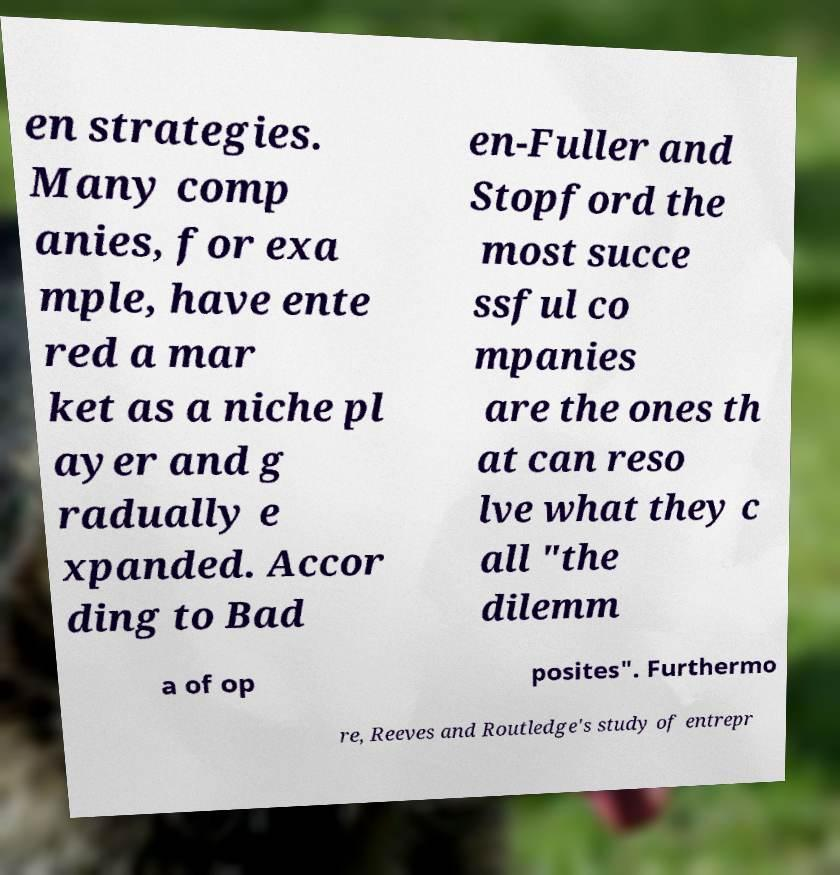Please read and relay the text visible in this image. What does it say? en strategies. Many comp anies, for exa mple, have ente red a mar ket as a niche pl ayer and g radually e xpanded. Accor ding to Bad en-Fuller and Stopford the most succe ssful co mpanies are the ones th at can reso lve what they c all "the dilemm a of op posites". Furthermo re, Reeves and Routledge's study of entrepr 